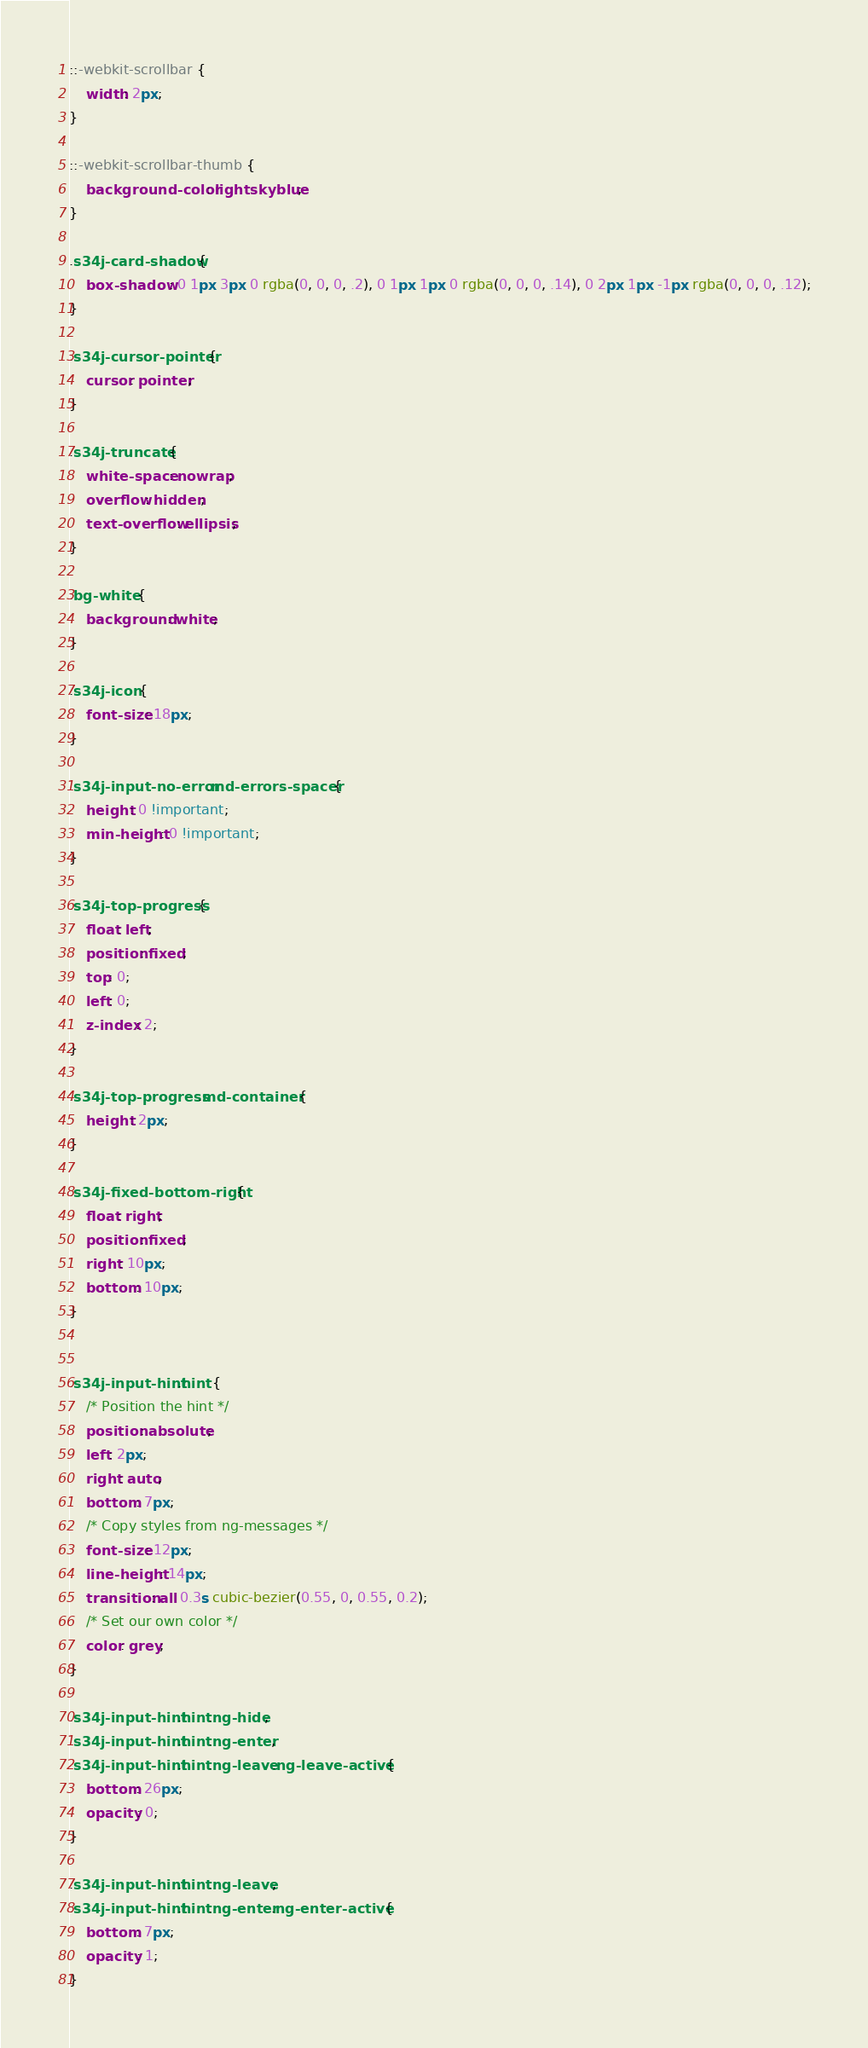Convert code to text. <code><loc_0><loc_0><loc_500><loc_500><_CSS_>::-webkit-scrollbar {
    width: 2px;
}

::-webkit-scrollbar-thumb {
    background-color: lightskyblue;
}

.s34j-card-shadow {
    box-shadow: 0 1px 3px 0 rgba(0, 0, 0, .2), 0 1px 1px 0 rgba(0, 0, 0, .14), 0 2px 1px -1px rgba(0, 0, 0, .12);
}

.s34j-cursor-pointer {
    cursor: pointer;
}

.s34j-truncate {
    white-space: nowrap;
    overflow: hidden;
    text-overflow: ellipsis;
}

.bg-white {
    background: white;
}

.s34j-icon {
    font-size: 18px;
}

.s34j-input-no-error .md-errors-spacer {
    height: 0 !important;
    min-height: 0 !important;
}

.s34j-top-progress {
    float: left;
    position: fixed;
    top: 0;
    left: 0;
    z-index: 2;
}

.s34j-top-progress .md-container {
    height: 2px;
}

.s34j-fixed-bottom-right {
    float: right;
    position: fixed;
    right: 10px;
    bottom: 10px;
}


.s34j-input-hint .hint {
    /* Position the hint */
    position: absolute;
    left: 2px;
    right: auto;
    bottom: 7px;
    /* Copy styles from ng-messages */
    font-size: 12px;
    line-height: 14px;
    transition: all 0.3s cubic-bezier(0.55, 0, 0.55, 0.2);
    /* Set our own color */
    color: grey;
}

.s34j-input-hint .hint.ng-hide,
.s34j-input-hint .hint.ng-enter,
.s34j-input-hint .hint.ng-leave.ng-leave-active {
    bottom: 26px;
    opacity: 0;
}

.s34j-input-hint .hint.ng-leave,
.s34j-input-hint .hint.ng-enter.ng-enter-active {
    bottom: 7px;
    opacity: 1;
}</code> 